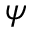<formula> <loc_0><loc_0><loc_500><loc_500>\psi</formula> 